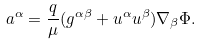<formula> <loc_0><loc_0><loc_500><loc_500>a ^ { \alpha } = \frac { q } { \mu } ( g ^ { \alpha \beta } + u ^ { \alpha } u ^ { \beta } ) \nabla _ { \beta } \Phi .</formula> 